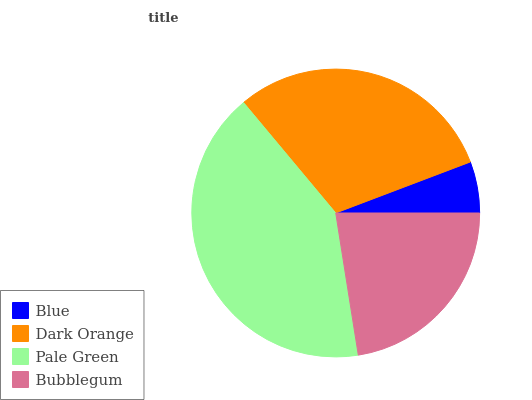Is Blue the minimum?
Answer yes or no. Yes. Is Pale Green the maximum?
Answer yes or no. Yes. Is Dark Orange the minimum?
Answer yes or no. No. Is Dark Orange the maximum?
Answer yes or no. No. Is Dark Orange greater than Blue?
Answer yes or no. Yes. Is Blue less than Dark Orange?
Answer yes or no. Yes. Is Blue greater than Dark Orange?
Answer yes or no. No. Is Dark Orange less than Blue?
Answer yes or no. No. Is Dark Orange the high median?
Answer yes or no. Yes. Is Bubblegum the low median?
Answer yes or no. Yes. Is Bubblegum the high median?
Answer yes or no. No. Is Dark Orange the low median?
Answer yes or no. No. 